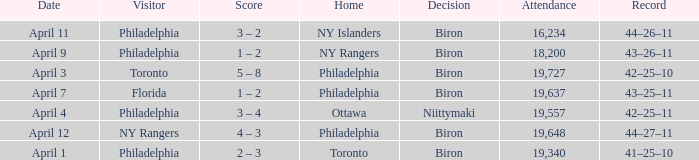What was the flyers' record when the visitors were florida? 43–25–11. 